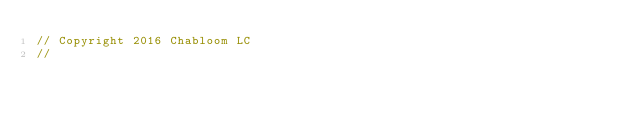Convert code to text. <code><loc_0><loc_0><loc_500><loc_500><_C++_>// Copyright 2016 Chabloom LC
//</code> 